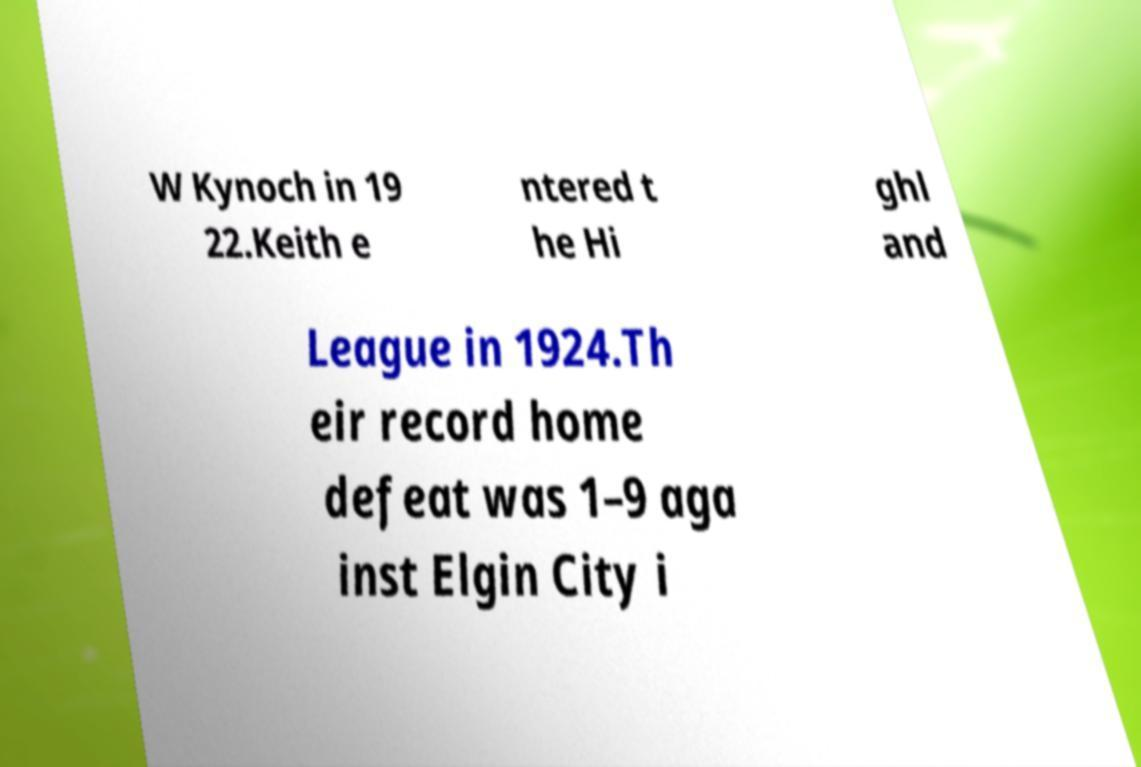Please read and relay the text visible in this image. What does it say? W Kynoch in 19 22.Keith e ntered t he Hi ghl and League in 1924.Th eir record home defeat was 1–9 aga inst Elgin City i 